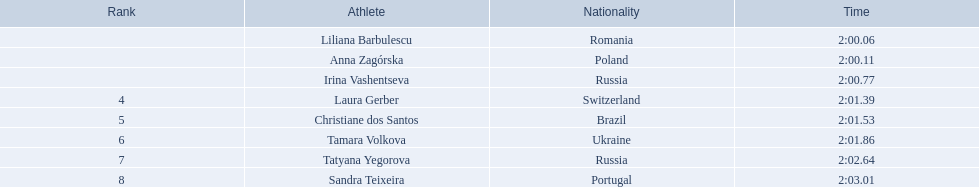What are the designations of the opponents? Liliana Barbulescu, Anna Zagórska, Irina Vashentseva, Laura Gerber, Christiane dos Santos, Tamara Volkova, Tatyana Yegorova, Sandra Teixeira. Which finalist accomplished the speediest? Liliana Barbulescu. What were the completion times for everyone? 2:00.06, 2:00.11, 2:00.77, 2:01.39, 2:01.53, 2:01.86, 2:02.64, 2:03.01. Can you identify anna zagorska's time among them? 2:00.11. 